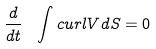Convert formula to latex. <formula><loc_0><loc_0><loc_500><loc_500>\frac { d } { d t } \ \int c u r l V d S = 0</formula> 